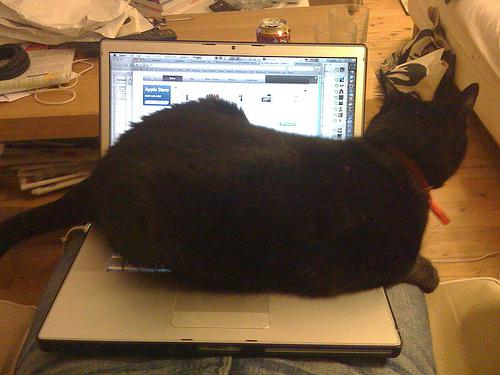Question: what animal is shown?
Choices:
A. A dog.
B. A cat.
C. A bear.
D. A lion.
Answer with the letter. Answer: B Question: where is the cat?
Choices:
A. On the couch.
B. On the floor.
C. Laying on a laptop.
D. On the bed.
Answer with the letter. Answer: C Question: how many cans are visible?
Choices:
A. Two.
B. Three.
C. One.
D. Four.
Answer with the letter. Answer: C Question: how many of the cat's feet are showing?
Choices:
A. Two.
B. Three.
C. Four.
D. One.
Answer with the letter. Answer: D Question: what color is the table?
Choices:
A. Brown.
B. Green.
C. Yellow.
D. Black.
Answer with the letter. Answer: A Question: how many people are there?
Choices:
A. One.
B. Three.
C. Two.
D. Four.
Answer with the letter. Answer: A 